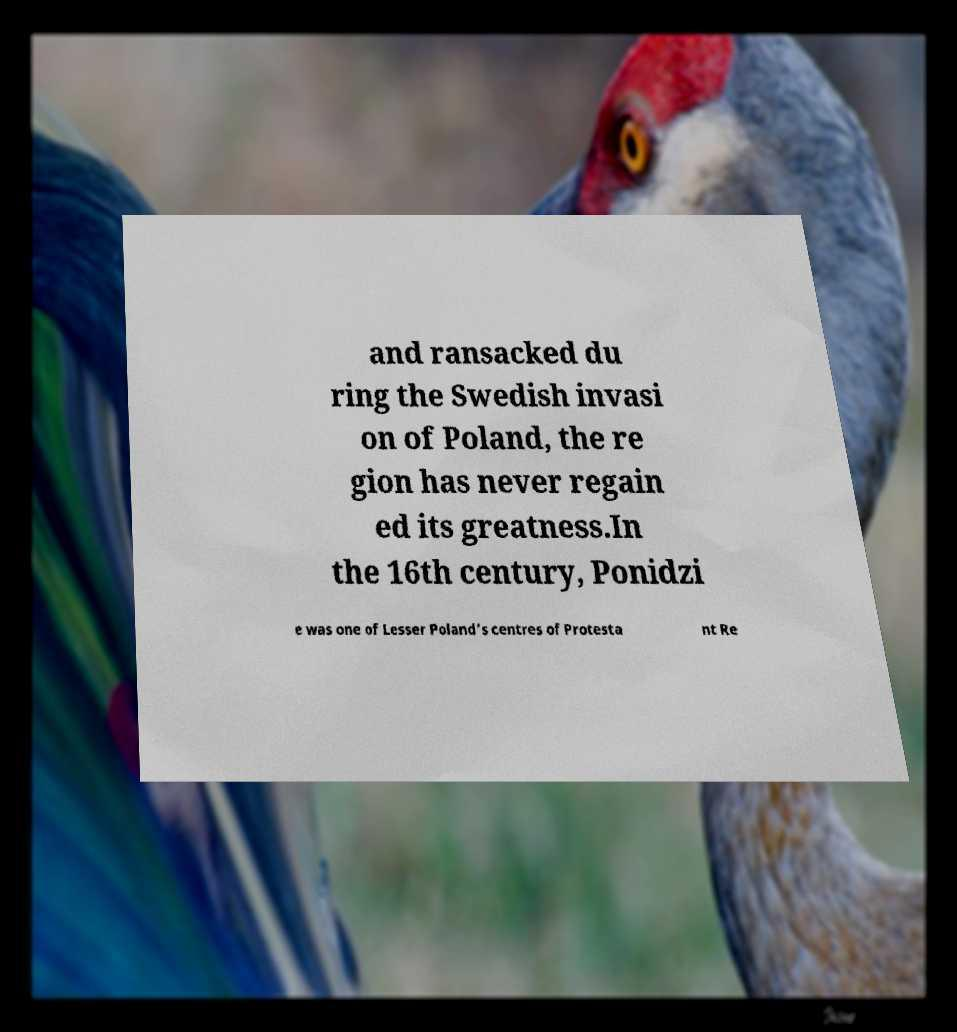Can you accurately transcribe the text from the provided image for me? and ransacked du ring the Swedish invasi on of Poland, the re gion has never regain ed its greatness.In the 16th century, Ponidzi e was one of Lesser Poland’s centres of Protesta nt Re 